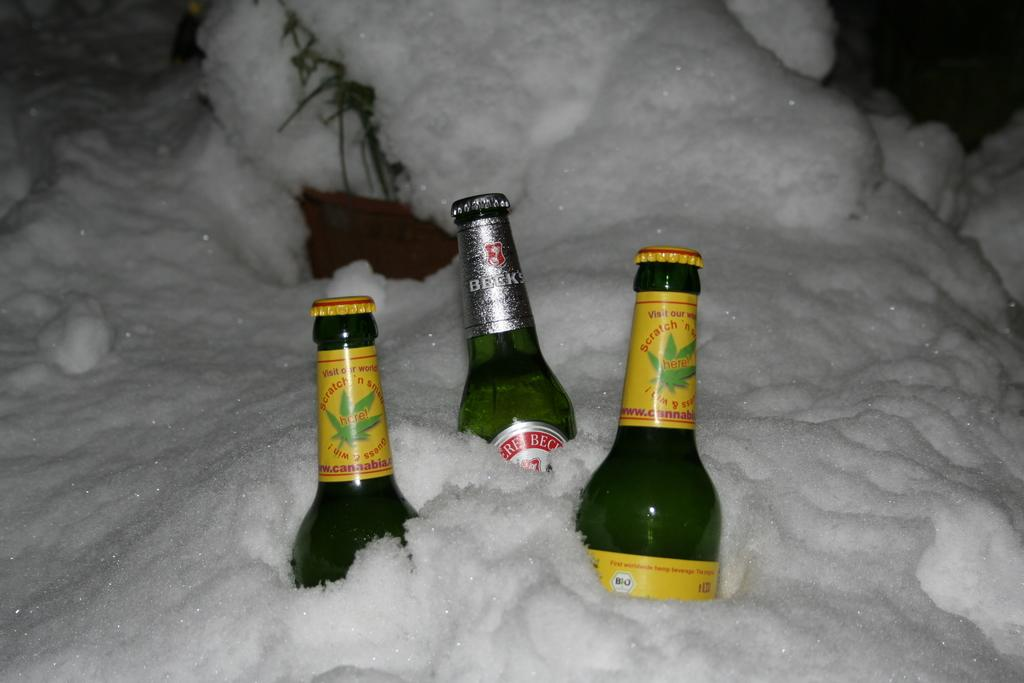What objects are present in the image? There are bottles in the image. How are the bottles affected by the environment? The bottles are covered in snow. What type of payment is being made for the crib in the image? There is no crib or payment present in the image; it only features bottles covered in snow. 